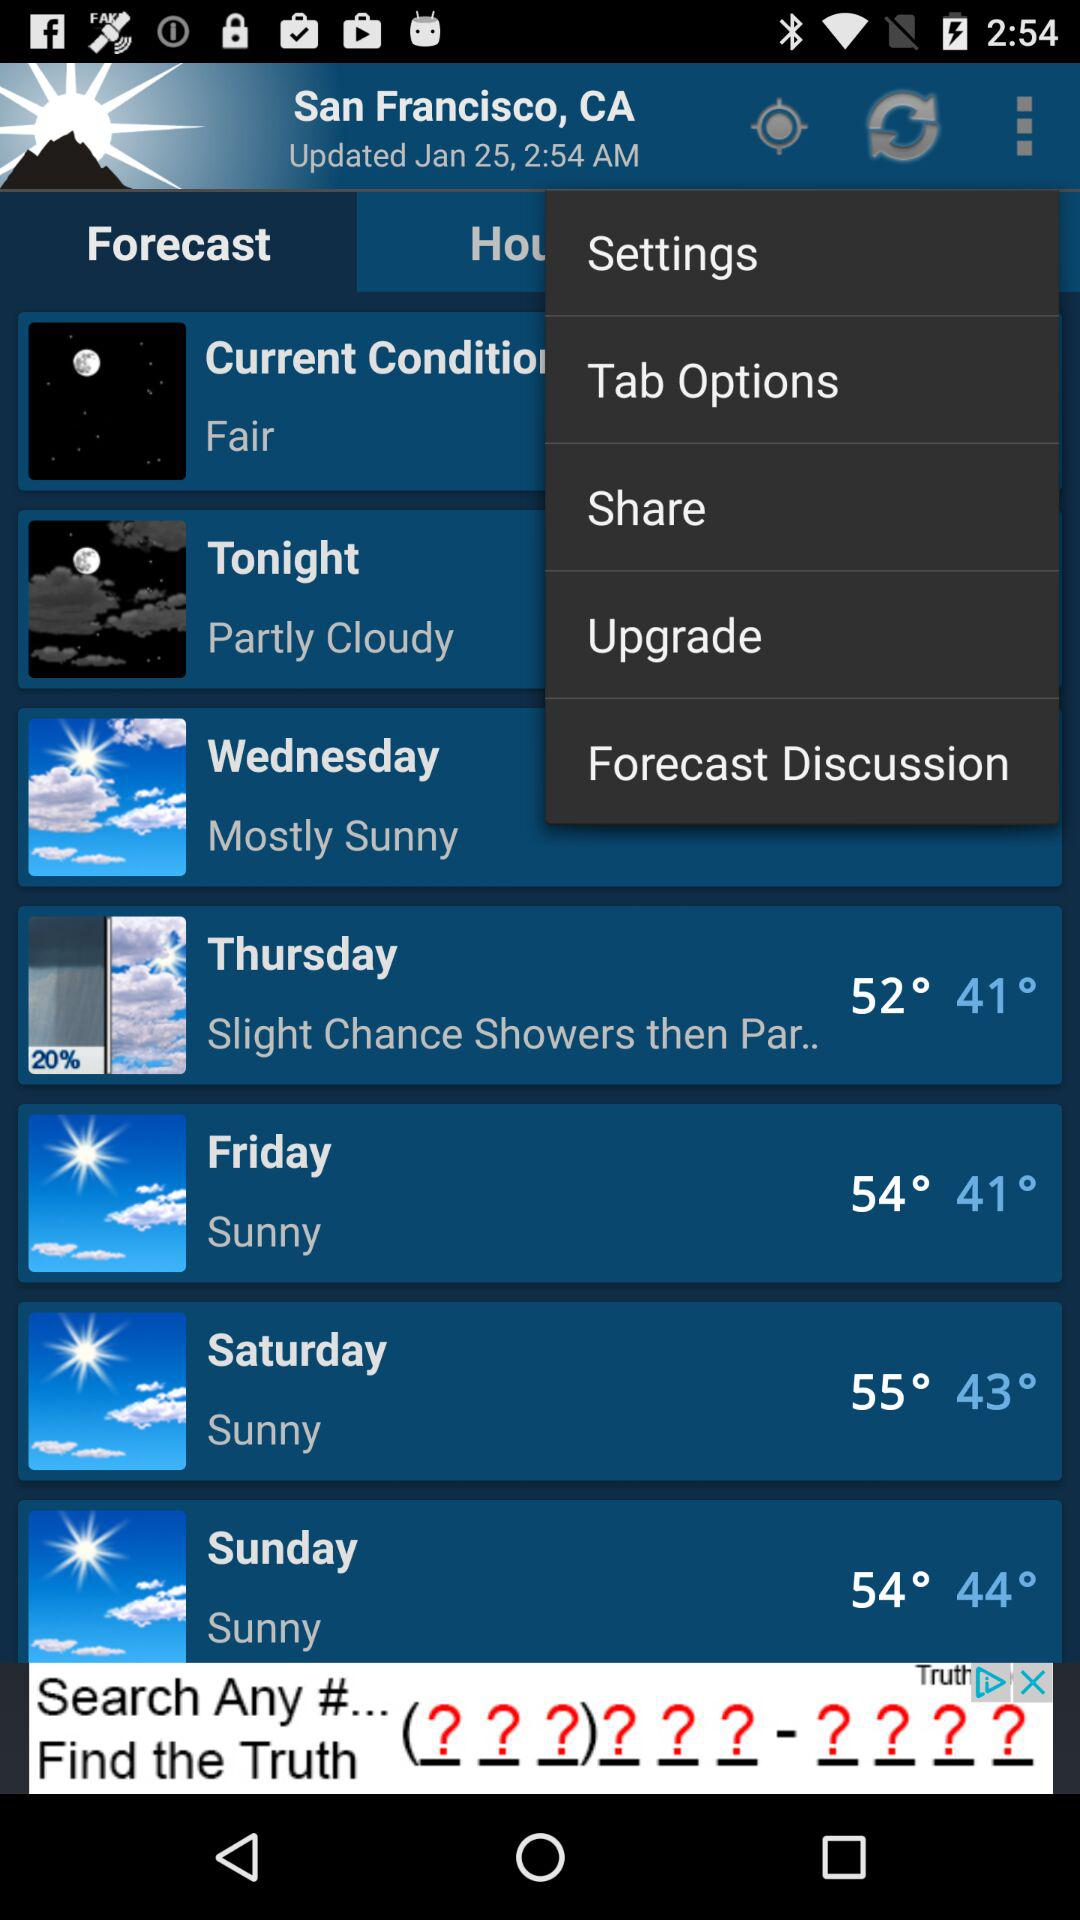How is the weather on Wednesday? The weather is mostly sunny. 